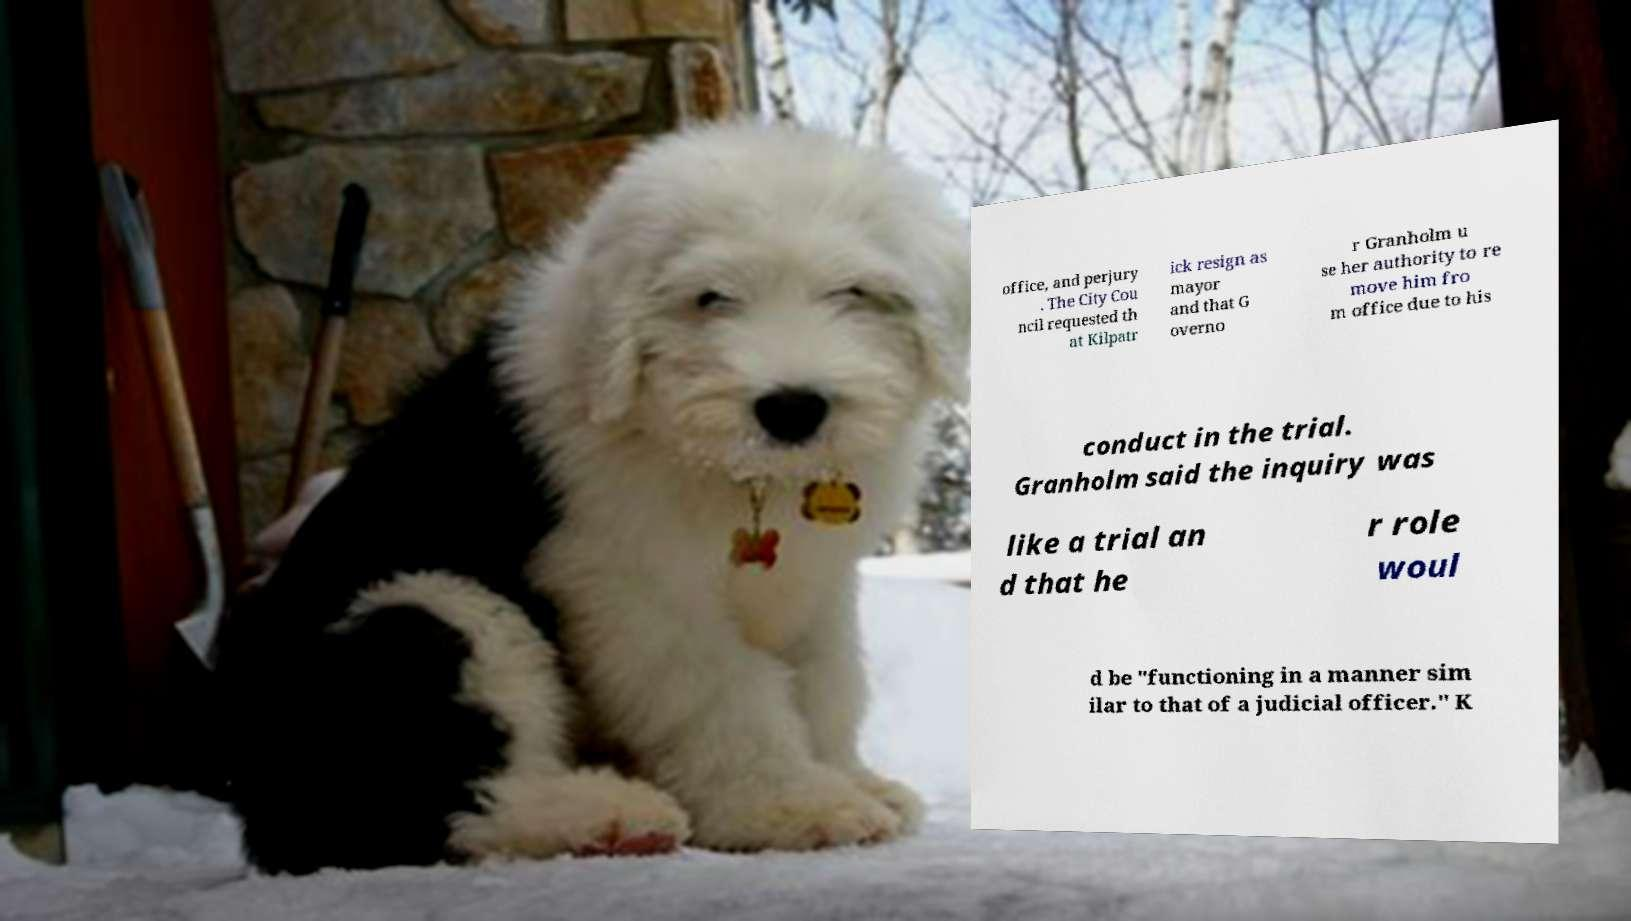For documentation purposes, I need the text within this image transcribed. Could you provide that? office, and perjury . The City Cou ncil requested th at Kilpatr ick resign as mayor and that G overno r Granholm u se her authority to re move him fro m office due to his conduct in the trial. Granholm said the inquiry was like a trial an d that he r role woul d be "functioning in a manner sim ilar to that of a judicial officer." K 